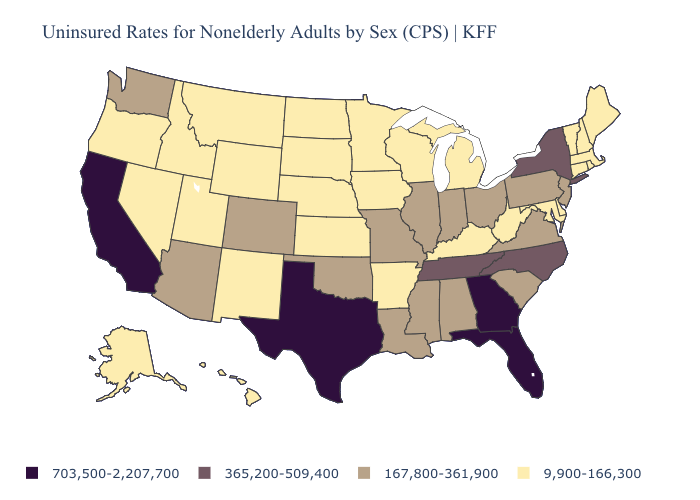Does the first symbol in the legend represent the smallest category?
Be succinct. No. What is the highest value in the South ?
Be succinct. 703,500-2,207,700. Which states have the lowest value in the USA?
Short answer required. Alaska, Arkansas, Connecticut, Delaware, Hawaii, Idaho, Iowa, Kansas, Kentucky, Maine, Maryland, Massachusetts, Michigan, Minnesota, Montana, Nebraska, Nevada, New Hampshire, New Mexico, North Dakota, Oregon, Rhode Island, South Dakota, Utah, Vermont, West Virginia, Wisconsin, Wyoming. Does Idaho have the same value as Kentucky?
Be succinct. Yes. Does California have the lowest value in the West?
Write a very short answer. No. What is the value of New York?
Be succinct. 365,200-509,400. Among the states that border Pennsylvania , does Delaware have the lowest value?
Concise answer only. Yes. What is the value of North Dakota?
Keep it brief. 9,900-166,300. What is the value of South Carolina?
Keep it brief. 167,800-361,900. What is the highest value in the USA?
Give a very brief answer. 703,500-2,207,700. What is the value of Arkansas?
Keep it brief. 9,900-166,300. Which states hav the highest value in the MidWest?
Answer briefly. Illinois, Indiana, Missouri, Ohio. Does the map have missing data?
Answer briefly. No. Name the states that have a value in the range 167,800-361,900?
Write a very short answer. Alabama, Arizona, Colorado, Illinois, Indiana, Louisiana, Mississippi, Missouri, New Jersey, Ohio, Oklahoma, Pennsylvania, South Carolina, Virginia, Washington. 